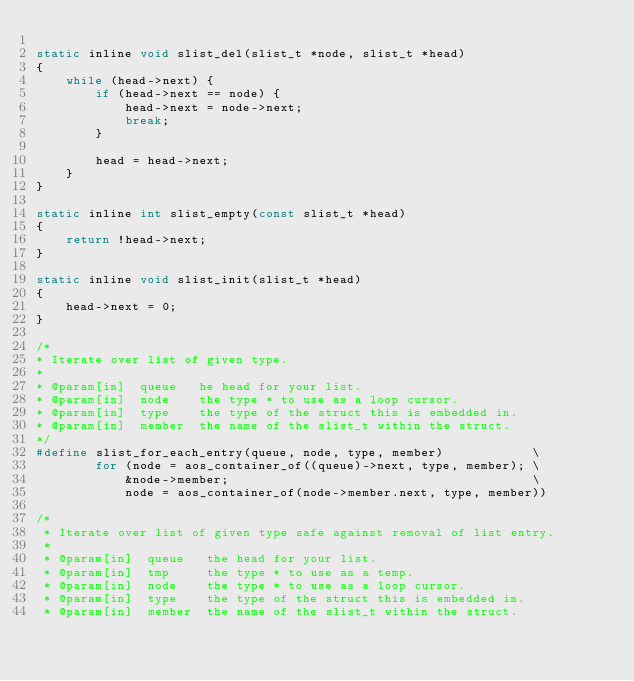Convert code to text. <code><loc_0><loc_0><loc_500><loc_500><_C_>
static inline void slist_del(slist_t *node, slist_t *head)
{
    while (head->next) {
        if (head->next == node) {
            head->next = node->next;
            break;
        }

        head = head->next;
    }
}

static inline int slist_empty(const slist_t *head)
{
    return !head->next;
}

static inline void slist_init(slist_t *head)
{
    head->next = 0;
}

/*
* Iterate over list of given type.
*
* @param[in]  queue   he head for your list.
* @param[in]  node    the type * to use as a loop cursor.
* @param[in]  type    the type of the struct this is embedded in.
* @param[in]  member  the name of the slist_t within the struct.
*/
#define slist_for_each_entry(queue, node, type, member)            \
        for (node = aos_container_of((queue)->next, type, member); \
            &node->member;                                         \
            node = aos_container_of(node->member.next, type, member))

/*
 * Iterate over list of given type safe against removal of list entry.
 *
 * @param[in]  queue   the head for your list.
 * @param[in]  tmp     the type * to use as a temp.
 * @param[in]  node    the type * to use as a loop cursor.
 * @param[in]  type    the type of the struct this is embedded in.
 * @param[in]  member  the name of the slist_t within the struct.</code> 